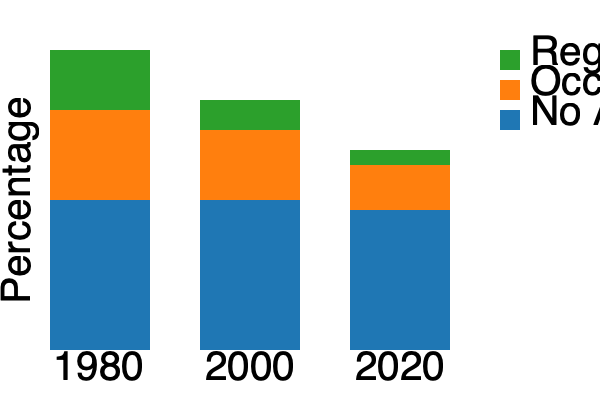Based on the stacked bar chart showing religious attendance patterns from 1980 to 2020, what trend can be observed regarding regular church attendance, and how might this reflect the impact of secularization on traditional religious institutions? To answer this question, we need to analyze the changes in the stacked bar chart over time:

1. Identify the category for regular attendance:
   The green bars at the top of each stack represent regular attendance.

2. Compare the height of green bars across years:
   1980: Approximately 20% of the total bar
   2000: Approximately 12% of the total bar
   2020: Approximately 7.5% of the total bar

3. Calculate the percentage decrease:
   From 1980 to 2020: (20% - 7.5%) / 20% * 100 ≈ 62.5% decrease

4. Analyze the trend:
   There is a clear downward trend in regular church attendance over the 40-year period.

5. Interpret the impact of secularization:
   The significant decrease in regular attendance suggests a declining influence of traditional religious institutions in people's lives, which is a key indicator of secularization.

6. Consider other factors:
   The increase in the "No Attendance" category (blue) further supports the secularization trend.

7. Reflect on the implications:
   This trend indicates a shift away from organized religion towards more individualized spiritual practices or non-religious lifestyles, consistent with secularization theory.
Answer: Regular church attendance decreased by approximately 62.5% from 1980 to 2020, indicating a significant secularization trend and declining influence of traditional religious institutions. 